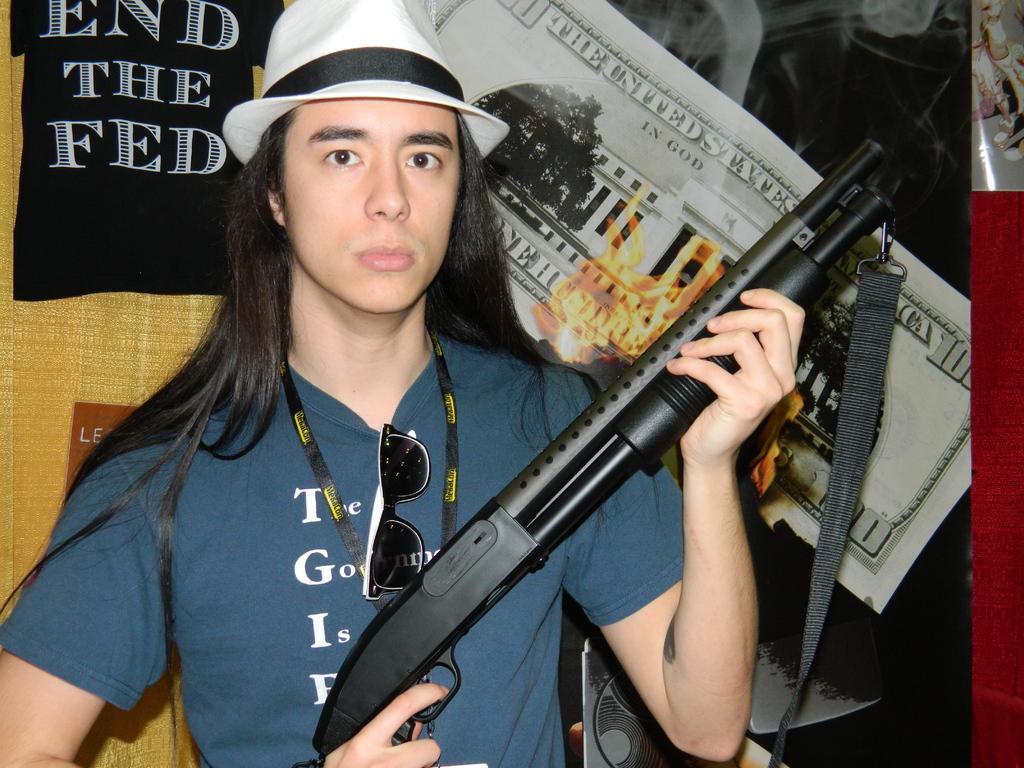In one or two sentences, can you explain what this image depicts? In this image we can see man is holding black color gun and wearing blue color t-shirt with white cap. Behind him posters are there. 